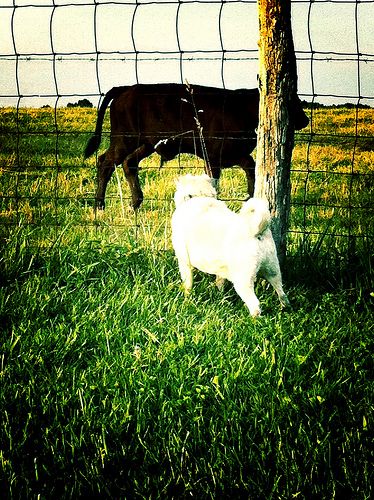<image>
Is there a grass on the cow? No. The grass is not positioned on the cow. They may be near each other, but the grass is not supported by or resting on top of the cow. Where is the cow in relation to the dog? Is it next to the dog? Yes. The cow is positioned adjacent to the dog, located nearby in the same general area. 